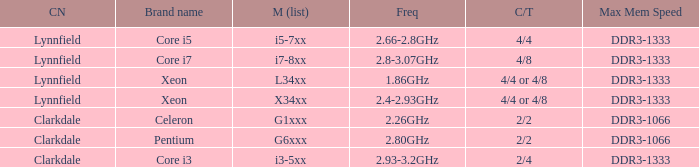What frequency does model L34xx use? 1.86GHz. 